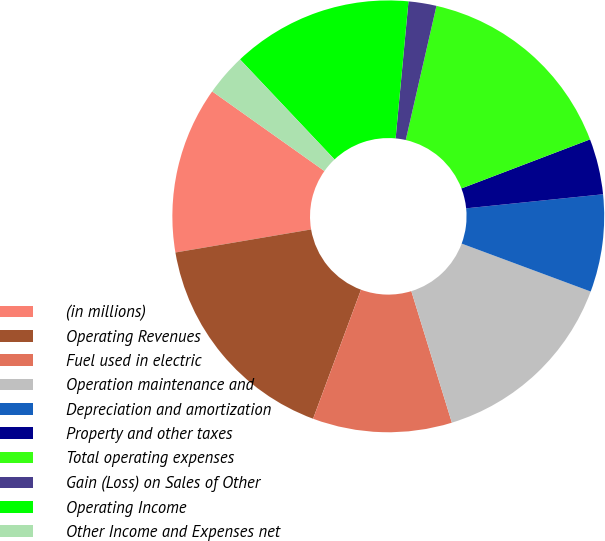Convert chart. <chart><loc_0><loc_0><loc_500><loc_500><pie_chart><fcel>(in millions)<fcel>Operating Revenues<fcel>Fuel used in electric<fcel>Operation maintenance and<fcel>Depreciation and amortization<fcel>Property and other taxes<fcel>Total operating expenses<fcel>Gain (Loss) on Sales of Other<fcel>Operating Income<fcel>Other Income and Expenses net<nl><fcel>12.5%<fcel>16.66%<fcel>10.42%<fcel>14.58%<fcel>7.29%<fcel>4.17%<fcel>15.62%<fcel>2.09%<fcel>13.54%<fcel>3.13%<nl></chart> 